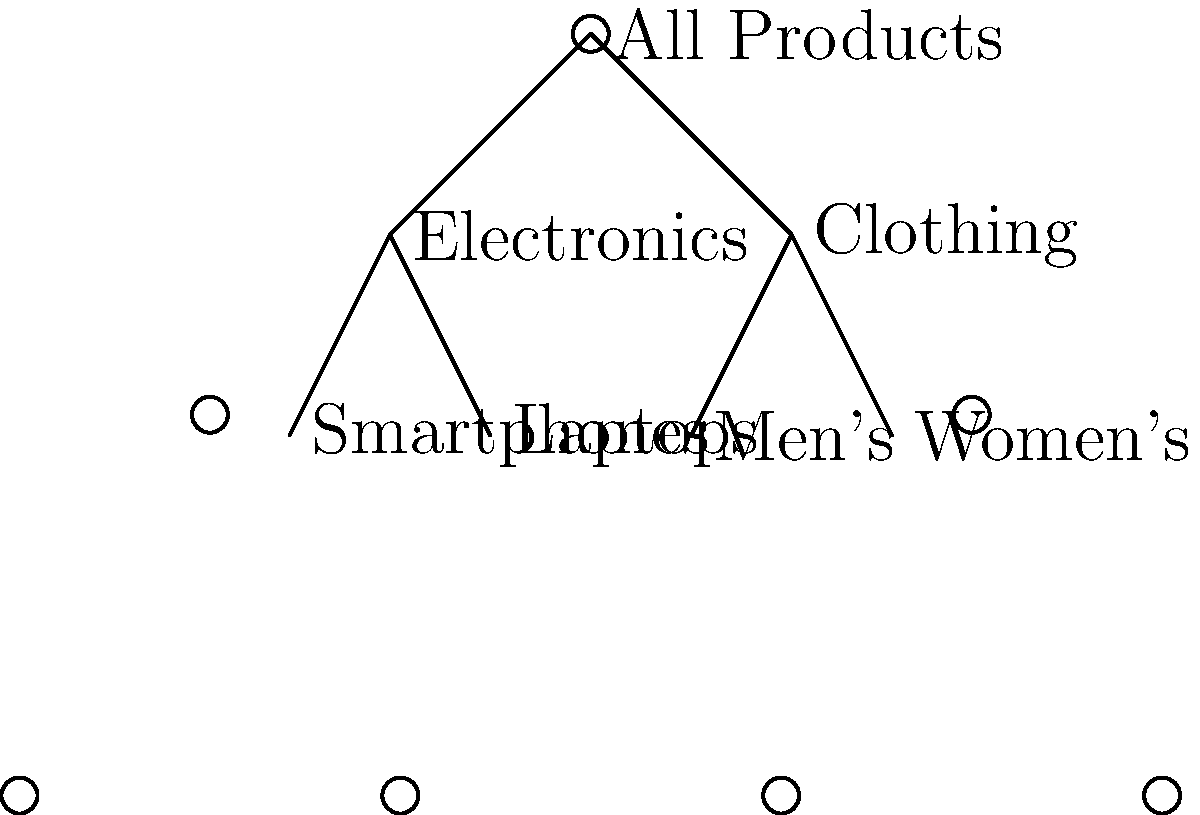Given the hierarchical tree structure for product categorization in an e-commerce store, what is the optimal depth for this structure to balance user navigation and SEO performance? To determine the optimal depth for the hierarchical tree structure, we need to consider several factors:

1. User Experience: 
   - Shallow structures (1-2 levels) can be too broad, making it difficult for users to find specific products.
   - Deep structures (4+ levels) can be confusing and require too many clicks to reach desired products.

2. SEO Performance:
   - Search engines prefer well-organized, logical structures.
   - Deeper categories can target more specific long-tail keywords.
   - However, excessively deep structures can dilute link equity and make it harder for search engines to crawl all pages.

3. Product Variety:
   - The depth should accommodate the range of products without creating unnecessarily specific categories.

4. Industry Standards:
   - Most successful e-commerce sites use 2-3 levels of categorization.

5. Scalability:
   - The structure should allow for future expansion without major reorganization.

Analyzing the given structure:
- It has 3 levels: All Products → Main Categories (Electronics, Clothing) → Subcategories
- This depth allows for clear organization while keeping navigation simple.
- It provides enough specificity for effective SEO without being overly complex.
- It follows industry best practices.

Therefore, the optimal depth for this structure is 3 levels, as it balances user navigation ease with SEO performance and allows for future scalability.
Answer: 3 levels 